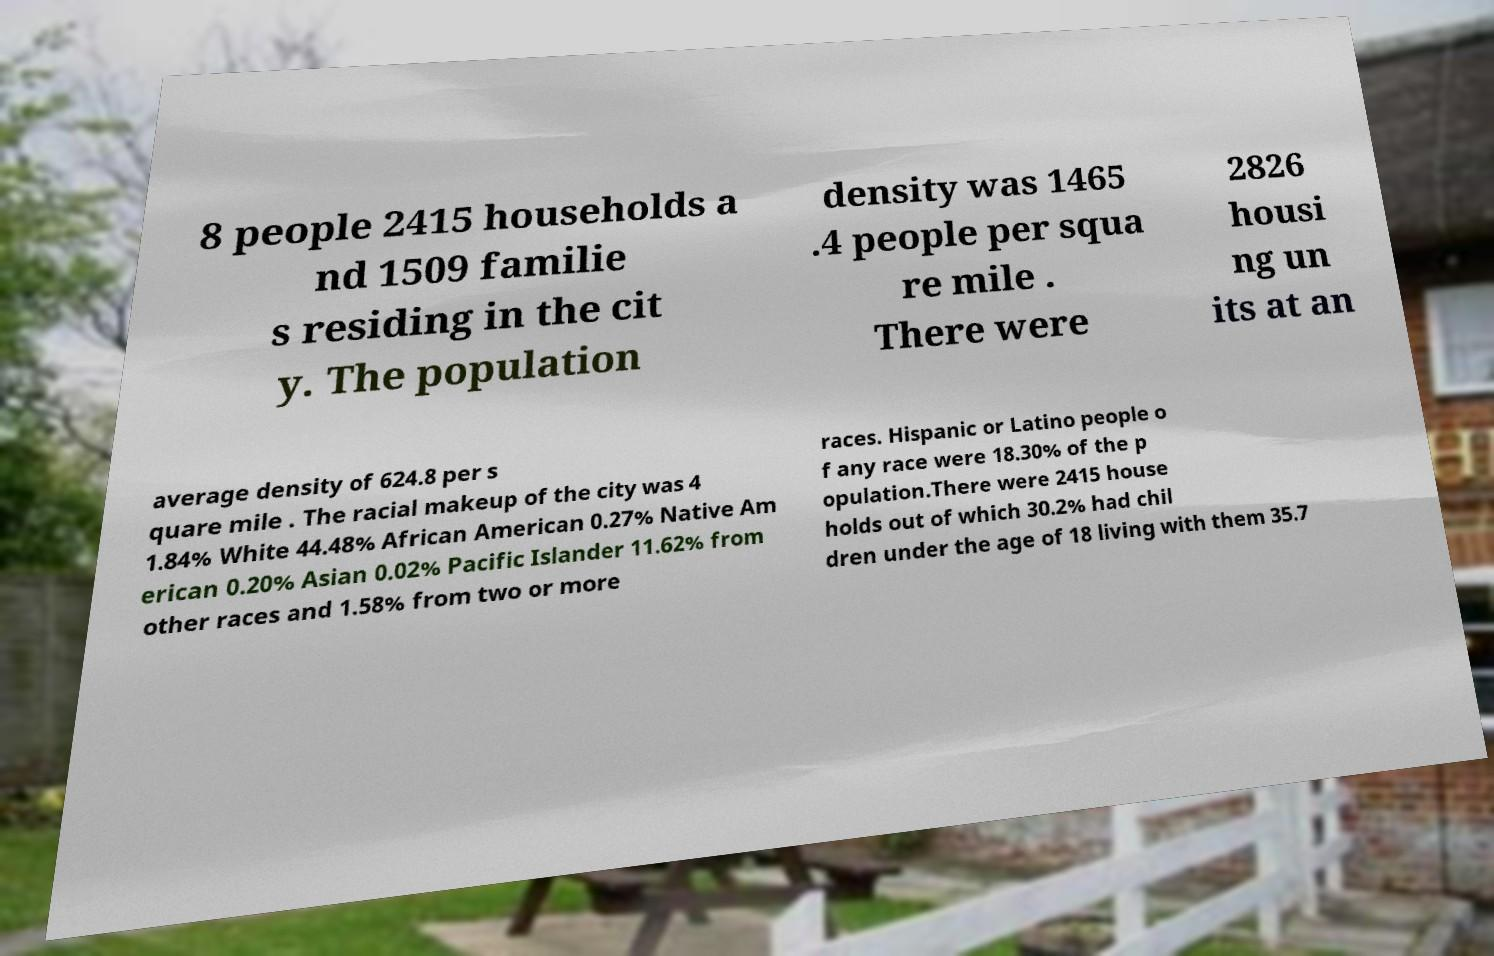There's text embedded in this image that I need extracted. Can you transcribe it verbatim? 8 people 2415 households a nd 1509 familie s residing in the cit y. The population density was 1465 .4 people per squa re mile . There were 2826 housi ng un its at an average density of 624.8 per s quare mile . The racial makeup of the city was 4 1.84% White 44.48% African American 0.27% Native Am erican 0.20% Asian 0.02% Pacific Islander 11.62% from other races and 1.58% from two or more races. Hispanic or Latino people o f any race were 18.30% of the p opulation.There were 2415 house holds out of which 30.2% had chil dren under the age of 18 living with them 35.7 